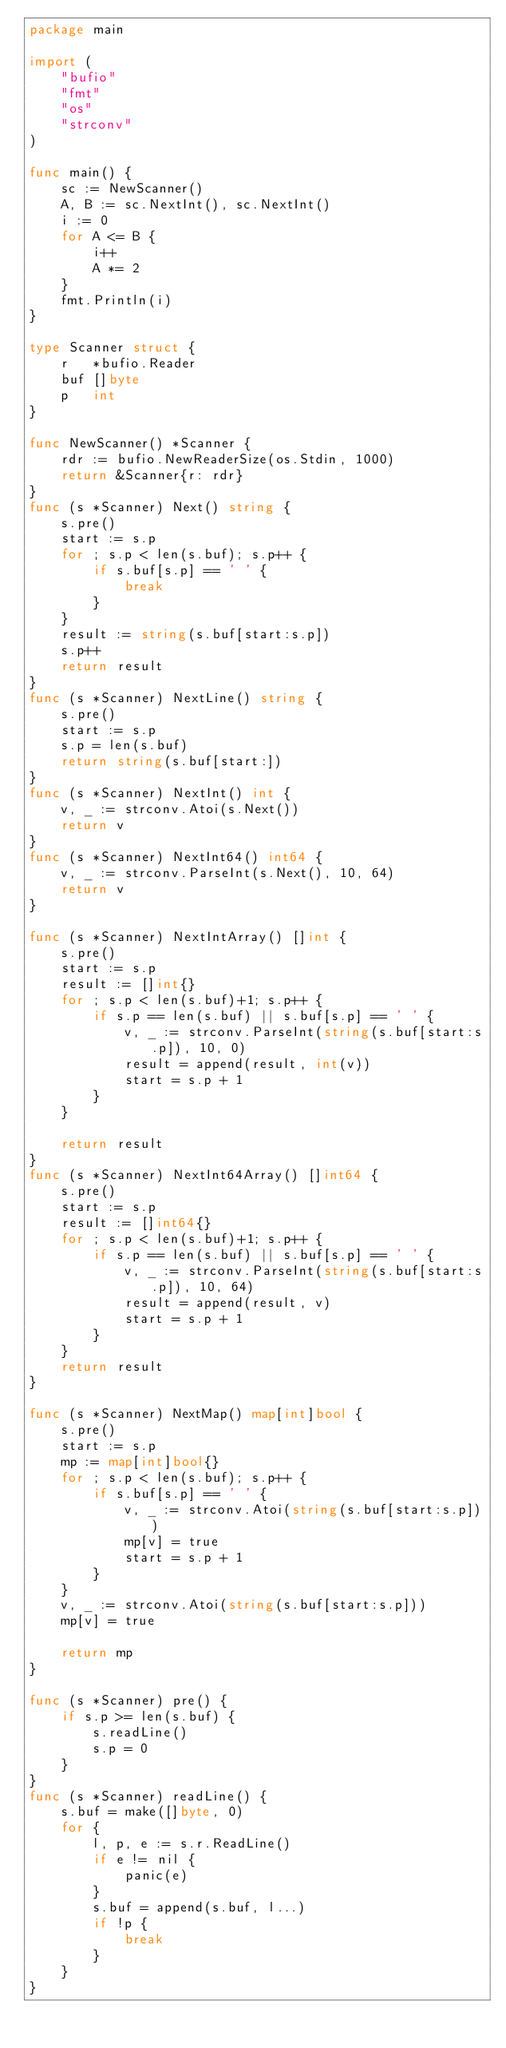<code> <loc_0><loc_0><loc_500><loc_500><_Go_>package main

import (
	"bufio"
	"fmt"
	"os"
	"strconv"
)

func main() {
	sc := NewScanner()
	A, B := sc.NextInt(), sc.NextInt()
	i := 0
	for A <= B {
		i++
		A *= 2
	}
	fmt.Println(i)
}

type Scanner struct {
	r   *bufio.Reader
	buf []byte
	p   int
}

func NewScanner() *Scanner {
	rdr := bufio.NewReaderSize(os.Stdin, 1000)
	return &Scanner{r: rdr}
}
func (s *Scanner) Next() string {
	s.pre()
	start := s.p
	for ; s.p < len(s.buf); s.p++ {
		if s.buf[s.p] == ' ' {
			break
		}
	}
	result := string(s.buf[start:s.p])
	s.p++
	return result
}
func (s *Scanner) NextLine() string {
	s.pre()
	start := s.p
	s.p = len(s.buf)
	return string(s.buf[start:])
}
func (s *Scanner) NextInt() int {
	v, _ := strconv.Atoi(s.Next())
	return v
}
func (s *Scanner) NextInt64() int64 {
	v, _ := strconv.ParseInt(s.Next(), 10, 64)
	return v
}

func (s *Scanner) NextIntArray() []int {
	s.pre()
	start := s.p
	result := []int{}
	for ; s.p < len(s.buf)+1; s.p++ {
		if s.p == len(s.buf) || s.buf[s.p] == ' ' {
			v, _ := strconv.ParseInt(string(s.buf[start:s.p]), 10, 0)
			result = append(result, int(v))
			start = s.p + 1
		}
	}

	return result
}
func (s *Scanner) NextInt64Array() []int64 {
	s.pre()
	start := s.p
	result := []int64{}
	for ; s.p < len(s.buf)+1; s.p++ {
		if s.p == len(s.buf) || s.buf[s.p] == ' ' {
			v, _ := strconv.ParseInt(string(s.buf[start:s.p]), 10, 64)
			result = append(result, v)
			start = s.p + 1
		}
	}
	return result
}

func (s *Scanner) NextMap() map[int]bool {
	s.pre()
	start := s.p
	mp := map[int]bool{}
	for ; s.p < len(s.buf); s.p++ {
		if s.buf[s.p] == ' ' {
			v, _ := strconv.Atoi(string(s.buf[start:s.p]))
			mp[v] = true
			start = s.p + 1
		}
	}
	v, _ := strconv.Atoi(string(s.buf[start:s.p]))
	mp[v] = true

	return mp
}

func (s *Scanner) pre() {
	if s.p >= len(s.buf) {
		s.readLine()
		s.p = 0
	}
}
func (s *Scanner) readLine() {
	s.buf = make([]byte, 0)
	for {
		l, p, e := s.r.ReadLine()
		if e != nil {
			panic(e)
		}
		s.buf = append(s.buf, l...)
		if !p {
			break
		}
	}
}
</code> 